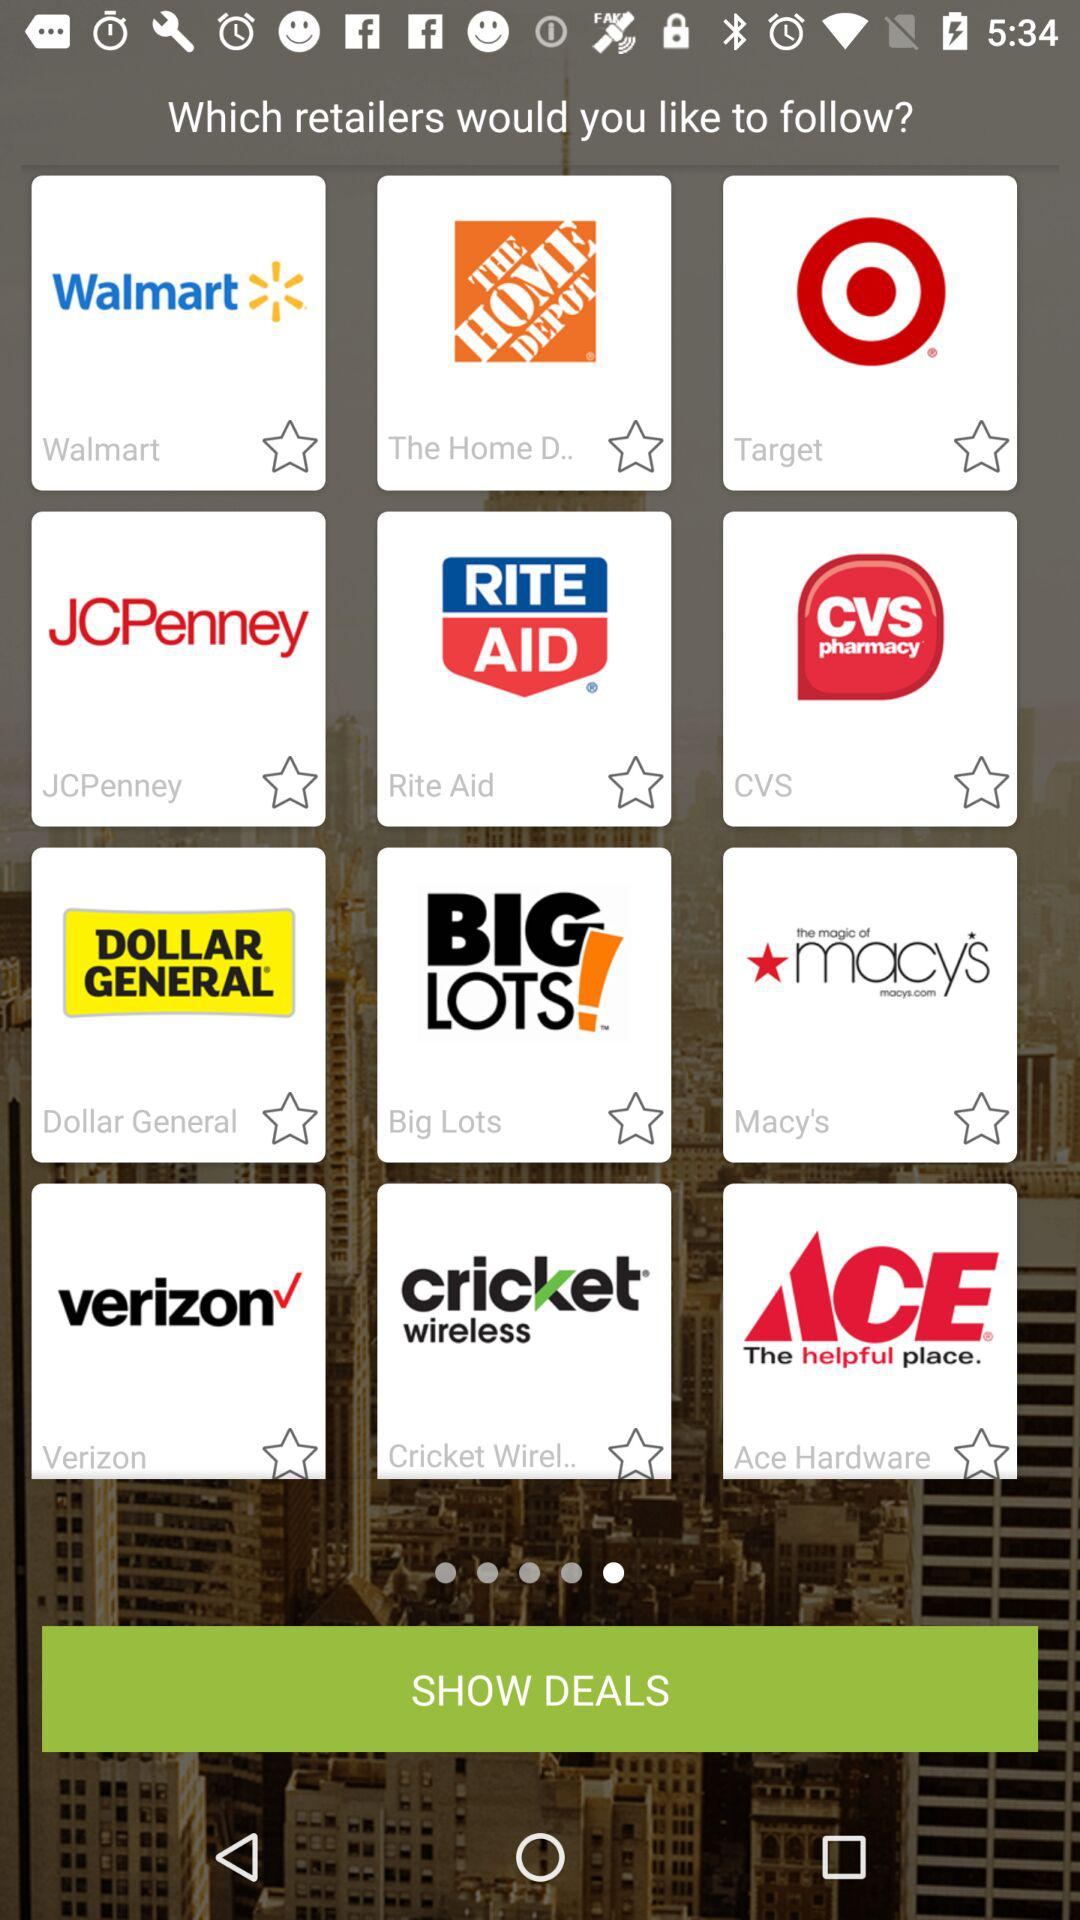How many retailers are available?
When the provided information is insufficient, respond with <no answer>. <no answer> 